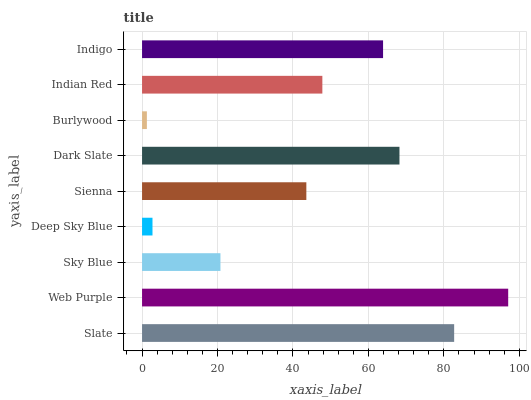Is Burlywood the minimum?
Answer yes or no. Yes. Is Web Purple the maximum?
Answer yes or no. Yes. Is Sky Blue the minimum?
Answer yes or no. No. Is Sky Blue the maximum?
Answer yes or no. No. Is Web Purple greater than Sky Blue?
Answer yes or no. Yes. Is Sky Blue less than Web Purple?
Answer yes or no. Yes. Is Sky Blue greater than Web Purple?
Answer yes or no. No. Is Web Purple less than Sky Blue?
Answer yes or no. No. Is Indian Red the high median?
Answer yes or no. Yes. Is Indian Red the low median?
Answer yes or no. Yes. Is Sienna the high median?
Answer yes or no. No. Is Sienna the low median?
Answer yes or no. No. 